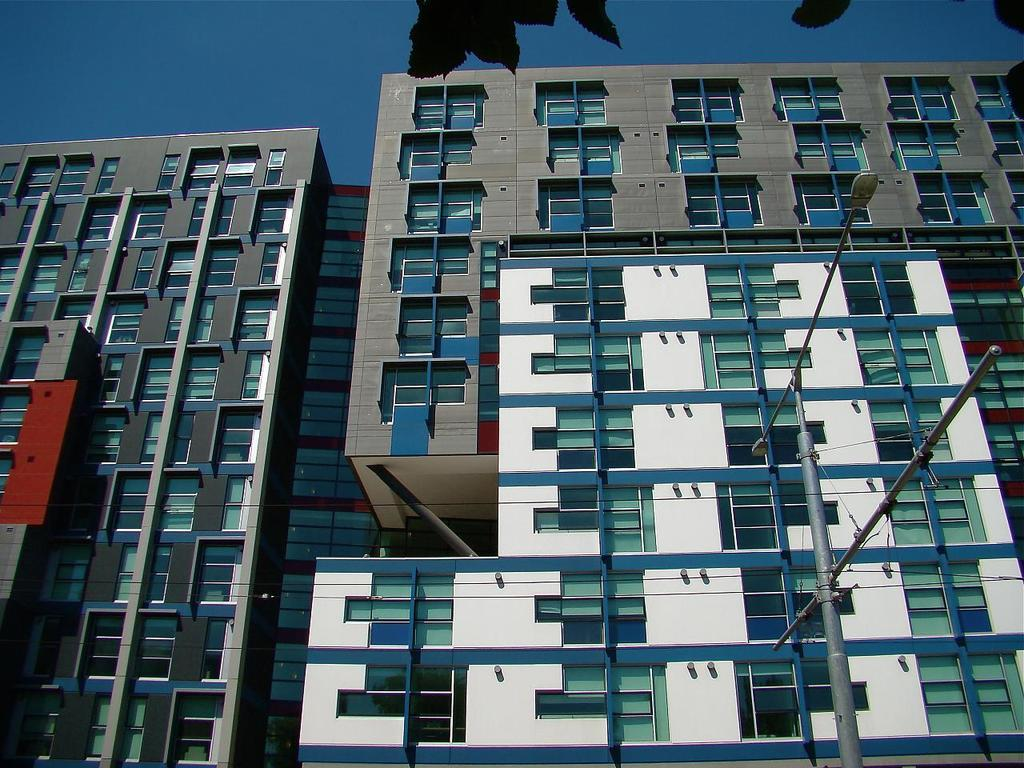What type of structures can be seen in the image? There are buildings in the image. What else can be found along the street in the image? There is a street pole and street lights in the image. What type of vegetation is present in the image? Leaves are present in the image. What is visible in the background of the image? The sky is visible in the image. How many bears can be seen wearing a ring on their toe in the image? There are no bears or rings present in the image. 